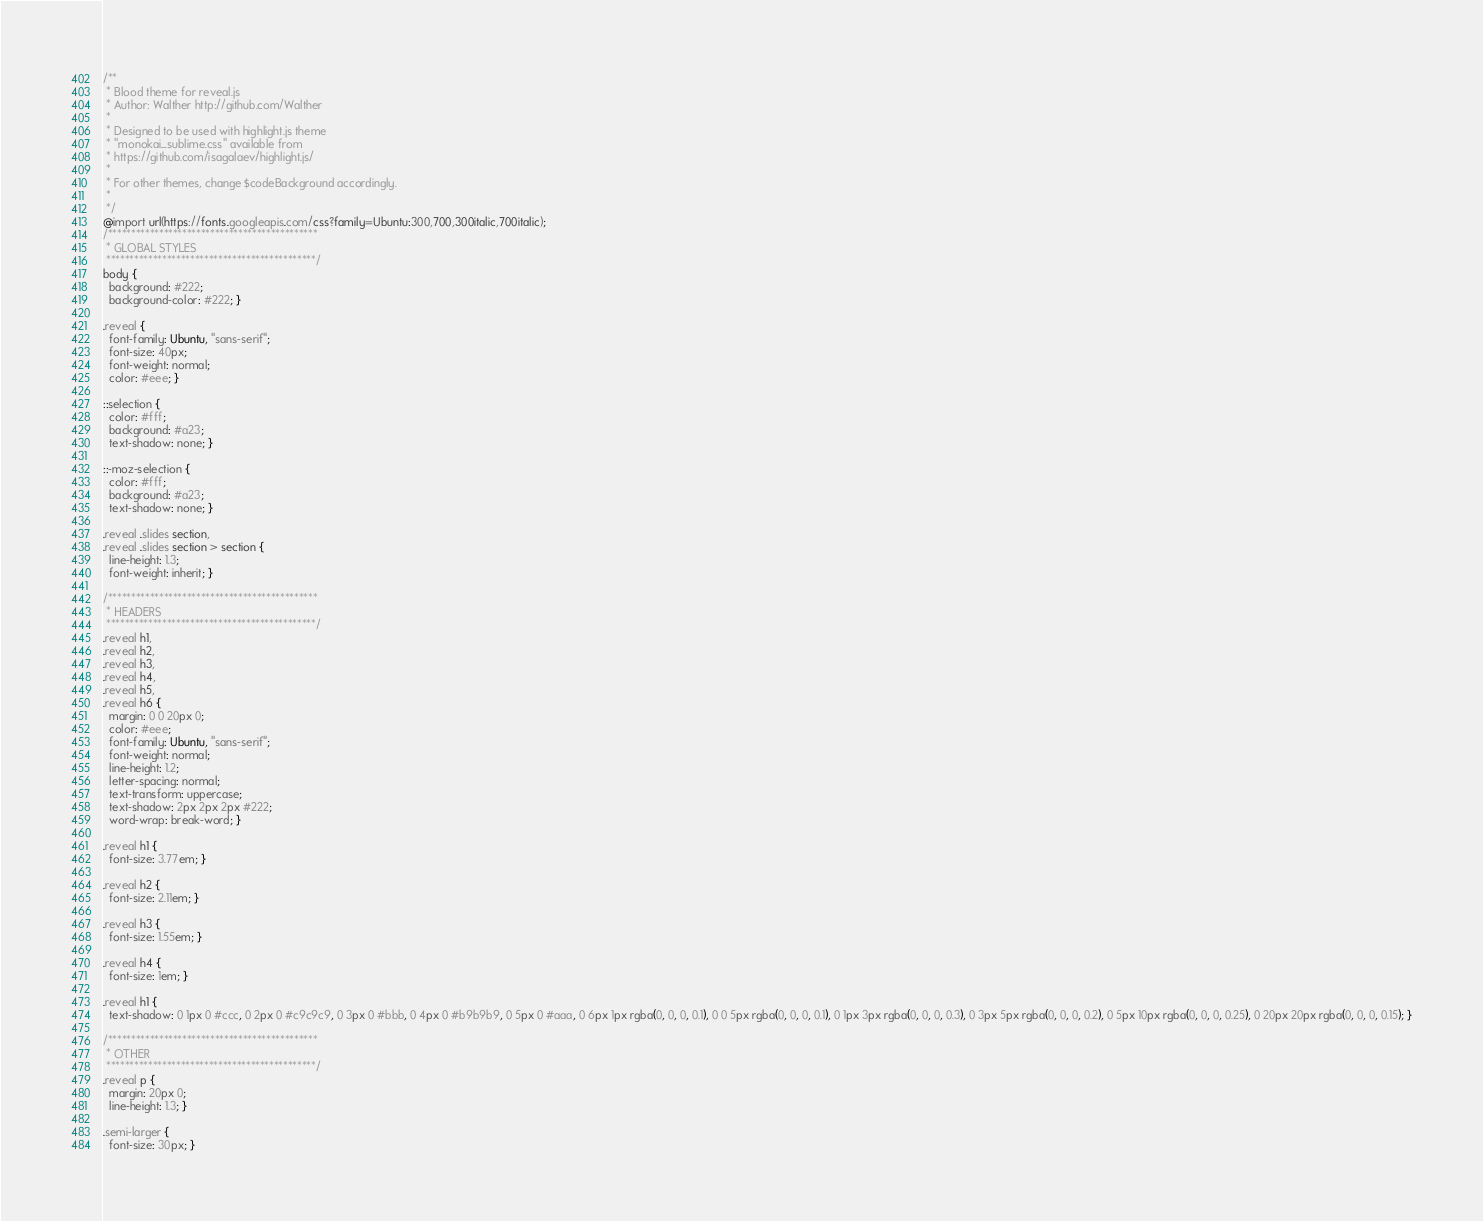<code> <loc_0><loc_0><loc_500><loc_500><_CSS_>/**
 * Blood theme for reveal.js
 * Author: Walther http://github.com/Walther
 *
 * Designed to be used with highlight.js theme
 * "monokai_sublime.css" available from
 * https://github.com/isagalaev/highlight.js/
 *
 * For other themes, change $codeBackground accordingly.
 *
 */
@import url(https://fonts.googleapis.com/css?family=Ubuntu:300,700,300italic,700italic);
/*********************************************
 * GLOBAL STYLES
 *********************************************/
body {
  background: #222;
  background-color: #222; }

.reveal {
  font-family: Ubuntu, "sans-serif";
  font-size: 40px;
  font-weight: normal;
  color: #eee; }

::selection {
  color: #fff;
  background: #a23;
  text-shadow: none; }

::-moz-selection {
  color: #fff;
  background: #a23;
  text-shadow: none; }

.reveal .slides section,
.reveal .slides section > section {
  line-height: 1.3;
  font-weight: inherit; }

/*********************************************
 * HEADERS
 *********************************************/
.reveal h1,
.reveal h2,
.reveal h3,
.reveal h4,
.reveal h5,
.reveal h6 {
  margin: 0 0 20px 0;
  color: #eee;
  font-family: Ubuntu, "sans-serif";
  font-weight: normal;
  line-height: 1.2;
  letter-spacing: normal;
  text-transform: uppercase;
  text-shadow: 2px 2px 2px #222;
  word-wrap: break-word; }

.reveal h1 {
  font-size: 3.77em; }

.reveal h2 {
  font-size: 2.11em; }

.reveal h3 {
  font-size: 1.55em; }

.reveal h4 {
  font-size: 1em; }

.reveal h1 {
  text-shadow: 0 1px 0 #ccc, 0 2px 0 #c9c9c9, 0 3px 0 #bbb, 0 4px 0 #b9b9b9, 0 5px 0 #aaa, 0 6px 1px rgba(0, 0, 0, 0.1), 0 0 5px rgba(0, 0, 0, 0.1), 0 1px 3px rgba(0, 0, 0, 0.3), 0 3px 5px rgba(0, 0, 0, 0.2), 0 5px 10px rgba(0, 0, 0, 0.25), 0 20px 20px rgba(0, 0, 0, 0.15); }

/*********************************************
 * OTHER
 *********************************************/
.reveal p {
  margin: 20px 0;
  line-height: 1.3; }

.semi-larger {
  font-size: 30px; }
</code> 